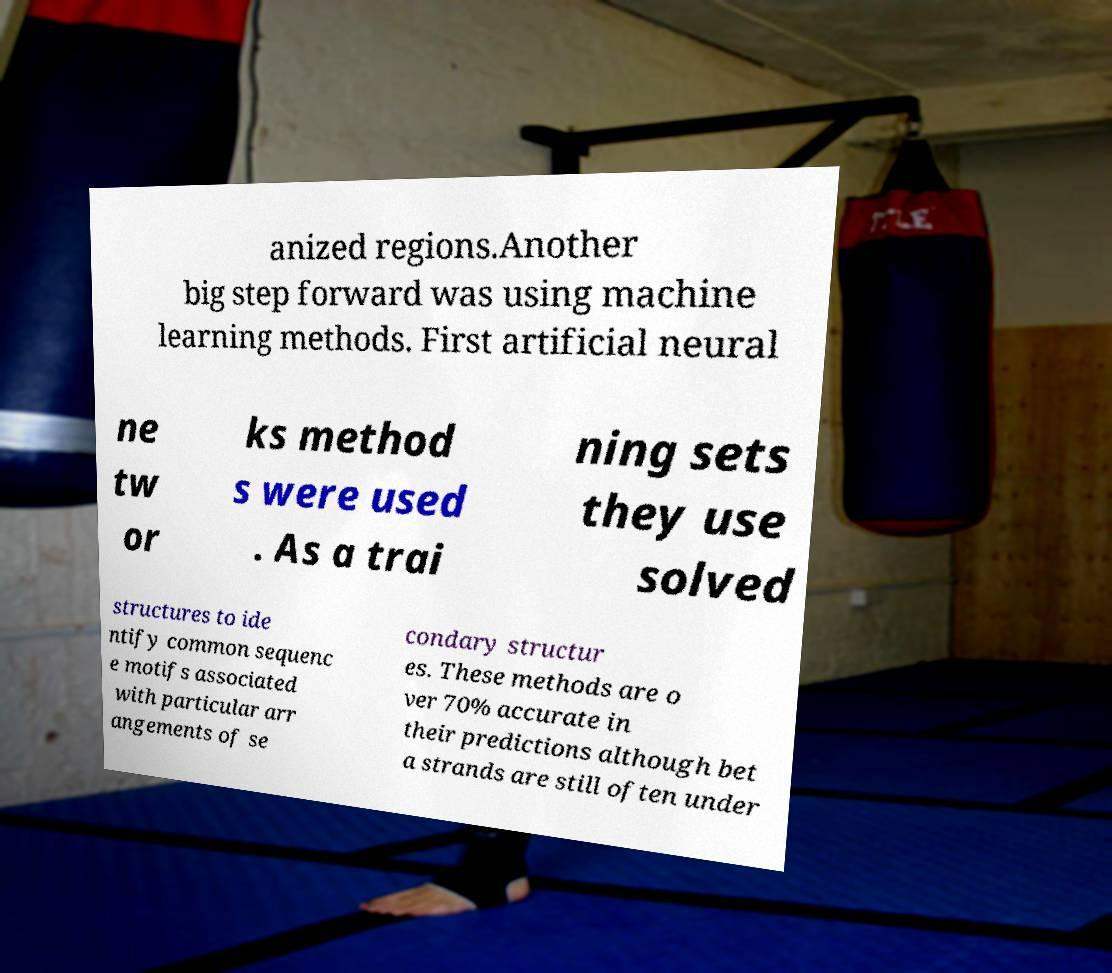Could you assist in decoding the text presented in this image and type it out clearly? anized regions.Another big step forward was using machine learning methods. First artificial neural ne tw or ks method s were used . As a trai ning sets they use solved structures to ide ntify common sequenc e motifs associated with particular arr angements of se condary structur es. These methods are o ver 70% accurate in their predictions although bet a strands are still often under 